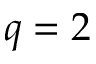Convert formula to latex. <formula><loc_0><loc_0><loc_500><loc_500>q = 2</formula> 